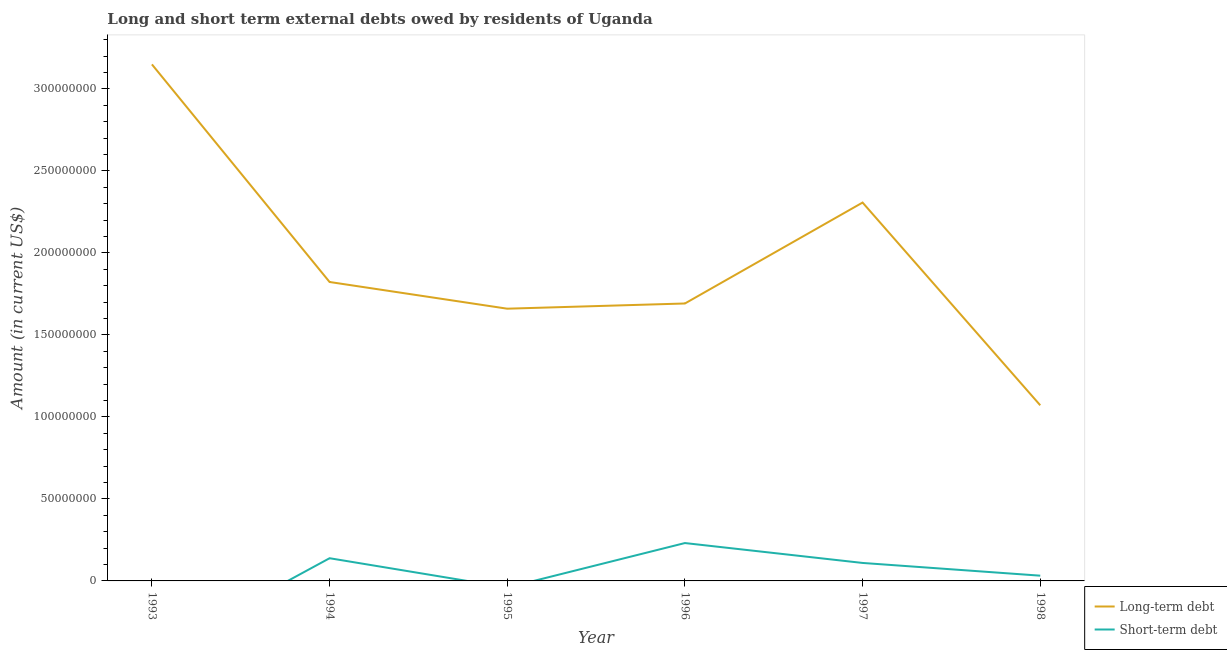How many different coloured lines are there?
Keep it short and to the point. 2. Does the line corresponding to long-term debts owed by residents intersect with the line corresponding to short-term debts owed by residents?
Offer a terse response. No. What is the short-term debts owed by residents in 1997?
Your response must be concise. 1.10e+07. Across all years, what is the maximum short-term debts owed by residents?
Your answer should be very brief. 2.31e+07. Across all years, what is the minimum long-term debts owed by residents?
Keep it short and to the point. 1.07e+08. In which year was the short-term debts owed by residents maximum?
Make the answer very short. 1996. What is the total short-term debts owed by residents in the graph?
Your response must be concise. 5.11e+07. What is the difference between the long-term debts owed by residents in 1996 and that in 1997?
Make the answer very short. -6.15e+07. What is the difference between the long-term debts owed by residents in 1996 and the short-term debts owed by residents in 1998?
Give a very brief answer. 1.66e+08. What is the average short-term debts owed by residents per year?
Your answer should be very brief. 8.52e+06. In the year 1997, what is the difference between the short-term debts owed by residents and long-term debts owed by residents?
Provide a succinct answer. -2.20e+08. What is the ratio of the long-term debts owed by residents in 1996 to that in 1998?
Offer a terse response. 1.58. Is the long-term debts owed by residents in 1993 less than that in 1998?
Give a very brief answer. No. What is the difference between the highest and the second highest short-term debts owed by residents?
Offer a very short reply. 9.25e+06. What is the difference between the highest and the lowest short-term debts owed by residents?
Keep it short and to the point. 2.31e+07. Does the short-term debts owed by residents monotonically increase over the years?
Give a very brief answer. No. Is the short-term debts owed by residents strictly greater than the long-term debts owed by residents over the years?
Keep it short and to the point. No. How many lines are there?
Provide a short and direct response. 2. How many years are there in the graph?
Keep it short and to the point. 6. What is the difference between two consecutive major ticks on the Y-axis?
Your answer should be compact. 5.00e+07. How are the legend labels stacked?
Give a very brief answer. Vertical. What is the title of the graph?
Keep it short and to the point. Long and short term external debts owed by residents of Uganda. What is the label or title of the X-axis?
Keep it short and to the point. Year. What is the label or title of the Y-axis?
Make the answer very short. Amount (in current US$). What is the Amount (in current US$) of Long-term debt in 1993?
Ensure brevity in your answer.  3.15e+08. What is the Amount (in current US$) of Short-term debt in 1993?
Offer a terse response. 0. What is the Amount (in current US$) of Long-term debt in 1994?
Provide a short and direct response. 1.82e+08. What is the Amount (in current US$) of Short-term debt in 1994?
Provide a short and direct response. 1.38e+07. What is the Amount (in current US$) in Long-term debt in 1995?
Offer a very short reply. 1.66e+08. What is the Amount (in current US$) in Short-term debt in 1995?
Offer a terse response. 0. What is the Amount (in current US$) of Long-term debt in 1996?
Keep it short and to the point. 1.69e+08. What is the Amount (in current US$) of Short-term debt in 1996?
Offer a very short reply. 2.31e+07. What is the Amount (in current US$) of Long-term debt in 1997?
Your answer should be compact. 2.31e+08. What is the Amount (in current US$) of Short-term debt in 1997?
Offer a terse response. 1.10e+07. What is the Amount (in current US$) in Long-term debt in 1998?
Keep it short and to the point. 1.07e+08. What is the Amount (in current US$) of Short-term debt in 1998?
Offer a very short reply. 3.20e+06. Across all years, what is the maximum Amount (in current US$) in Long-term debt?
Provide a short and direct response. 3.15e+08. Across all years, what is the maximum Amount (in current US$) of Short-term debt?
Offer a terse response. 2.31e+07. Across all years, what is the minimum Amount (in current US$) in Long-term debt?
Ensure brevity in your answer.  1.07e+08. Across all years, what is the minimum Amount (in current US$) of Short-term debt?
Make the answer very short. 0. What is the total Amount (in current US$) in Long-term debt in the graph?
Provide a succinct answer. 1.17e+09. What is the total Amount (in current US$) in Short-term debt in the graph?
Offer a terse response. 5.11e+07. What is the difference between the Amount (in current US$) in Long-term debt in 1993 and that in 1994?
Your answer should be very brief. 1.33e+08. What is the difference between the Amount (in current US$) of Long-term debt in 1993 and that in 1995?
Provide a succinct answer. 1.49e+08. What is the difference between the Amount (in current US$) in Long-term debt in 1993 and that in 1996?
Offer a very short reply. 1.46e+08. What is the difference between the Amount (in current US$) in Long-term debt in 1993 and that in 1997?
Ensure brevity in your answer.  8.42e+07. What is the difference between the Amount (in current US$) of Long-term debt in 1993 and that in 1998?
Your answer should be compact. 2.08e+08. What is the difference between the Amount (in current US$) in Long-term debt in 1994 and that in 1995?
Offer a terse response. 1.63e+07. What is the difference between the Amount (in current US$) of Long-term debt in 1994 and that in 1996?
Your response must be concise. 1.31e+07. What is the difference between the Amount (in current US$) of Short-term debt in 1994 and that in 1996?
Provide a short and direct response. -9.25e+06. What is the difference between the Amount (in current US$) of Long-term debt in 1994 and that in 1997?
Your answer should be compact. -4.84e+07. What is the difference between the Amount (in current US$) in Short-term debt in 1994 and that in 1997?
Make the answer very short. 2.88e+06. What is the difference between the Amount (in current US$) of Long-term debt in 1994 and that in 1998?
Offer a terse response. 7.52e+07. What is the difference between the Amount (in current US$) in Short-term debt in 1994 and that in 1998?
Give a very brief answer. 1.06e+07. What is the difference between the Amount (in current US$) in Long-term debt in 1995 and that in 1996?
Offer a very short reply. -3.17e+06. What is the difference between the Amount (in current US$) in Long-term debt in 1995 and that in 1997?
Ensure brevity in your answer.  -6.47e+07. What is the difference between the Amount (in current US$) in Long-term debt in 1995 and that in 1998?
Provide a succinct answer. 5.89e+07. What is the difference between the Amount (in current US$) of Long-term debt in 1996 and that in 1997?
Provide a succinct answer. -6.15e+07. What is the difference between the Amount (in current US$) in Short-term debt in 1996 and that in 1997?
Ensure brevity in your answer.  1.21e+07. What is the difference between the Amount (in current US$) of Long-term debt in 1996 and that in 1998?
Make the answer very short. 6.21e+07. What is the difference between the Amount (in current US$) of Short-term debt in 1996 and that in 1998?
Offer a terse response. 1.99e+07. What is the difference between the Amount (in current US$) of Long-term debt in 1997 and that in 1998?
Offer a terse response. 1.24e+08. What is the difference between the Amount (in current US$) in Short-term debt in 1997 and that in 1998?
Your response must be concise. 7.76e+06. What is the difference between the Amount (in current US$) in Long-term debt in 1993 and the Amount (in current US$) in Short-term debt in 1994?
Make the answer very short. 3.01e+08. What is the difference between the Amount (in current US$) of Long-term debt in 1993 and the Amount (in current US$) of Short-term debt in 1996?
Provide a succinct answer. 2.92e+08. What is the difference between the Amount (in current US$) of Long-term debt in 1993 and the Amount (in current US$) of Short-term debt in 1997?
Offer a very short reply. 3.04e+08. What is the difference between the Amount (in current US$) in Long-term debt in 1993 and the Amount (in current US$) in Short-term debt in 1998?
Your answer should be compact. 3.12e+08. What is the difference between the Amount (in current US$) of Long-term debt in 1994 and the Amount (in current US$) of Short-term debt in 1996?
Offer a very short reply. 1.59e+08. What is the difference between the Amount (in current US$) of Long-term debt in 1994 and the Amount (in current US$) of Short-term debt in 1997?
Ensure brevity in your answer.  1.71e+08. What is the difference between the Amount (in current US$) of Long-term debt in 1994 and the Amount (in current US$) of Short-term debt in 1998?
Provide a succinct answer. 1.79e+08. What is the difference between the Amount (in current US$) of Long-term debt in 1995 and the Amount (in current US$) of Short-term debt in 1996?
Make the answer very short. 1.43e+08. What is the difference between the Amount (in current US$) in Long-term debt in 1995 and the Amount (in current US$) in Short-term debt in 1997?
Offer a terse response. 1.55e+08. What is the difference between the Amount (in current US$) in Long-term debt in 1995 and the Amount (in current US$) in Short-term debt in 1998?
Make the answer very short. 1.63e+08. What is the difference between the Amount (in current US$) of Long-term debt in 1996 and the Amount (in current US$) of Short-term debt in 1997?
Offer a very short reply. 1.58e+08. What is the difference between the Amount (in current US$) of Long-term debt in 1996 and the Amount (in current US$) of Short-term debt in 1998?
Offer a very short reply. 1.66e+08. What is the difference between the Amount (in current US$) in Long-term debt in 1997 and the Amount (in current US$) in Short-term debt in 1998?
Offer a terse response. 2.27e+08. What is the average Amount (in current US$) in Long-term debt per year?
Give a very brief answer. 1.95e+08. What is the average Amount (in current US$) of Short-term debt per year?
Give a very brief answer. 8.52e+06. In the year 1994, what is the difference between the Amount (in current US$) of Long-term debt and Amount (in current US$) of Short-term debt?
Keep it short and to the point. 1.68e+08. In the year 1996, what is the difference between the Amount (in current US$) of Long-term debt and Amount (in current US$) of Short-term debt?
Keep it short and to the point. 1.46e+08. In the year 1997, what is the difference between the Amount (in current US$) of Long-term debt and Amount (in current US$) of Short-term debt?
Ensure brevity in your answer.  2.20e+08. In the year 1998, what is the difference between the Amount (in current US$) in Long-term debt and Amount (in current US$) in Short-term debt?
Make the answer very short. 1.04e+08. What is the ratio of the Amount (in current US$) in Long-term debt in 1993 to that in 1994?
Ensure brevity in your answer.  1.73. What is the ratio of the Amount (in current US$) of Long-term debt in 1993 to that in 1995?
Offer a very short reply. 1.9. What is the ratio of the Amount (in current US$) in Long-term debt in 1993 to that in 1996?
Your answer should be very brief. 1.86. What is the ratio of the Amount (in current US$) of Long-term debt in 1993 to that in 1997?
Offer a terse response. 1.37. What is the ratio of the Amount (in current US$) of Long-term debt in 1993 to that in 1998?
Keep it short and to the point. 2.94. What is the ratio of the Amount (in current US$) of Long-term debt in 1994 to that in 1995?
Provide a succinct answer. 1.1. What is the ratio of the Amount (in current US$) in Long-term debt in 1994 to that in 1996?
Your response must be concise. 1.08. What is the ratio of the Amount (in current US$) of Short-term debt in 1994 to that in 1996?
Your response must be concise. 0.6. What is the ratio of the Amount (in current US$) in Long-term debt in 1994 to that in 1997?
Provide a short and direct response. 0.79. What is the ratio of the Amount (in current US$) in Short-term debt in 1994 to that in 1997?
Ensure brevity in your answer.  1.26. What is the ratio of the Amount (in current US$) of Long-term debt in 1994 to that in 1998?
Your response must be concise. 1.7. What is the ratio of the Amount (in current US$) of Short-term debt in 1994 to that in 1998?
Ensure brevity in your answer.  4.33. What is the ratio of the Amount (in current US$) of Long-term debt in 1995 to that in 1996?
Give a very brief answer. 0.98. What is the ratio of the Amount (in current US$) in Long-term debt in 1995 to that in 1997?
Offer a terse response. 0.72. What is the ratio of the Amount (in current US$) in Long-term debt in 1995 to that in 1998?
Your response must be concise. 1.55. What is the ratio of the Amount (in current US$) in Long-term debt in 1996 to that in 1997?
Keep it short and to the point. 0.73. What is the ratio of the Amount (in current US$) in Short-term debt in 1996 to that in 1997?
Give a very brief answer. 2.11. What is the ratio of the Amount (in current US$) of Long-term debt in 1996 to that in 1998?
Your answer should be compact. 1.58. What is the ratio of the Amount (in current US$) in Short-term debt in 1996 to that in 1998?
Your answer should be very brief. 7.22. What is the ratio of the Amount (in current US$) in Long-term debt in 1997 to that in 1998?
Your answer should be compact. 2.15. What is the ratio of the Amount (in current US$) in Short-term debt in 1997 to that in 1998?
Provide a succinct answer. 3.42. What is the difference between the highest and the second highest Amount (in current US$) of Long-term debt?
Your answer should be very brief. 8.42e+07. What is the difference between the highest and the second highest Amount (in current US$) in Short-term debt?
Offer a very short reply. 9.25e+06. What is the difference between the highest and the lowest Amount (in current US$) in Long-term debt?
Your answer should be compact. 2.08e+08. What is the difference between the highest and the lowest Amount (in current US$) in Short-term debt?
Offer a terse response. 2.31e+07. 